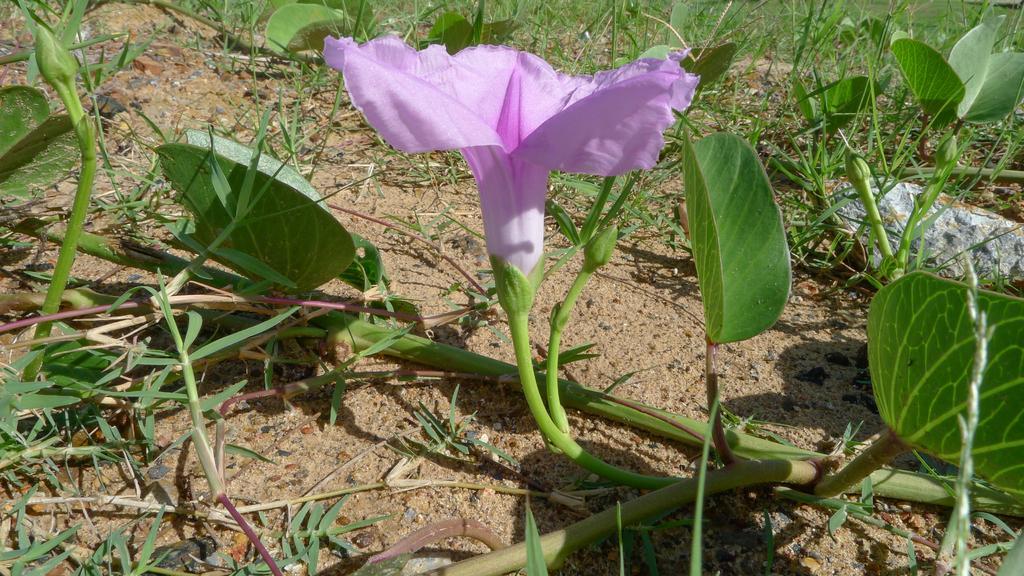How would you summarize this image in a sentence or two? In this image, we can see flower plants. 